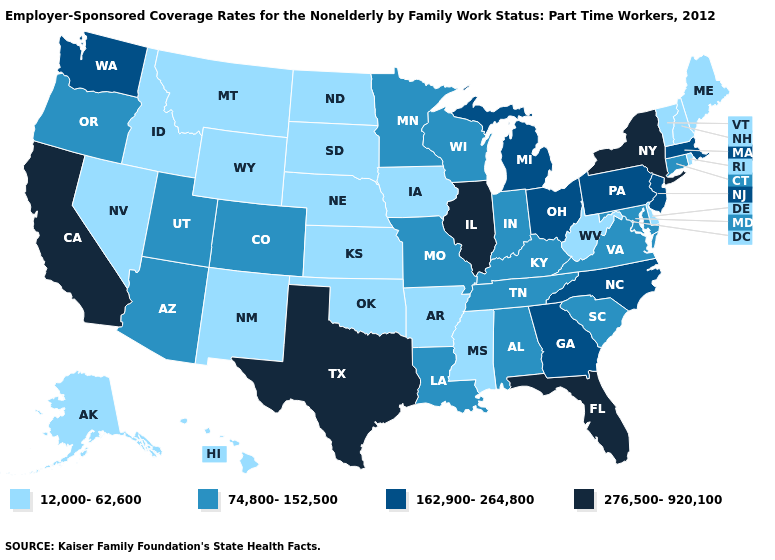What is the highest value in the USA?
Concise answer only. 276,500-920,100. What is the value of Kansas?
Be succinct. 12,000-62,600. Among the states that border North Dakota , does Minnesota have the highest value?
Short answer required. Yes. Name the states that have a value in the range 162,900-264,800?
Be succinct. Georgia, Massachusetts, Michigan, New Jersey, North Carolina, Ohio, Pennsylvania, Washington. Does Florida have the highest value in the USA?
Quick response, please. Yes. Name the states that have a value in the range 12,000-62,600?
Be succinct. Alaska, Arkansas, Delaware, Hawaii, Idaho, Iowa, Kansas, Maine, Mississippi, Montana, Nebraska, Nevada, New Hampshire, New Mexico, North Dakota, Oklahoma, Rhode Island, South Dakota, Vermont, West Virginia, Wyoming. Which states have the highest value in the USA?
Be succinct. California, Florida, Illinois, New York, Texas. Which states have the lowest value in the USA?
Give a very brief answer. Alaska, Arkansas, Delaware, Hawaii, Idaho, Iowa, Kansas, Maine, Mississippi, Montana, Nebraska, Nevada, New Hampshire, New Mexico, North Dakota, Oklahoma, Rhode Island, South Dakota, Vermont, West Virginia, Wyoming. Is the legend a continuous bar?
Quick response, please. No. What is the highest value in states that border Missouri?
Give a very brief answer. 276,500-920,100. Name the states that have a value in the range 162,900-264,800?
Concise answer only. Georgia, Massachusetts, Michigan, New Jersey, North Carolina, Ohio, Pennsylvania, Washington. Among the states that border Wyoming , does South Dakota have the lowest value?
Quick response, please. Yes. What is the highest value in the USA?
Be succinct. 276,500-920,100. How many symbols are there in the legend?
Be succinct. 4. Does the first symbol in the legend represent the smallest category?
Quick response, please. Yes. 